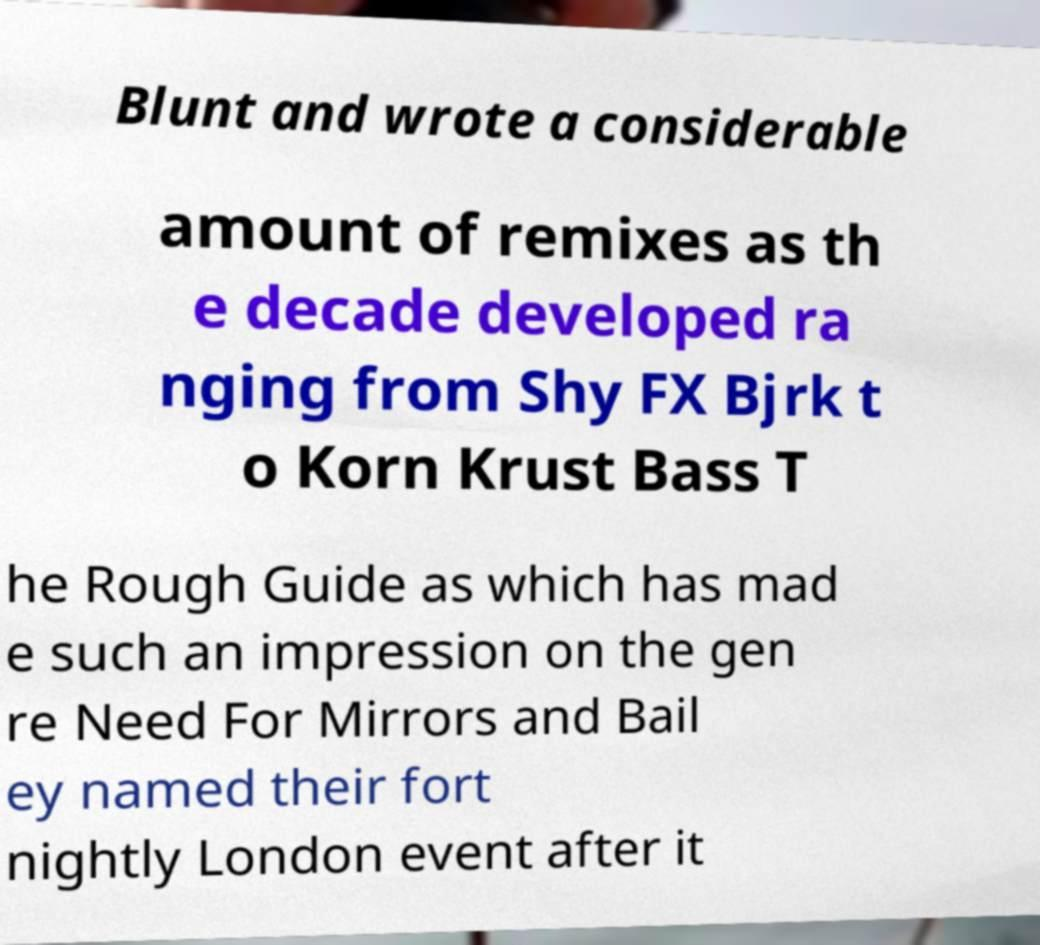Can you accurately transcribe the text from the provided image for me? Blunt and wrote a considerable amount of remixes as th e decade developed ra nging from Shy FX Bjrk t o Korn Krust Bass T he Rough Guide as which has mad e such an impression on the gen re Need For Mirrors and Bail ey named their fort nightly London event after it 